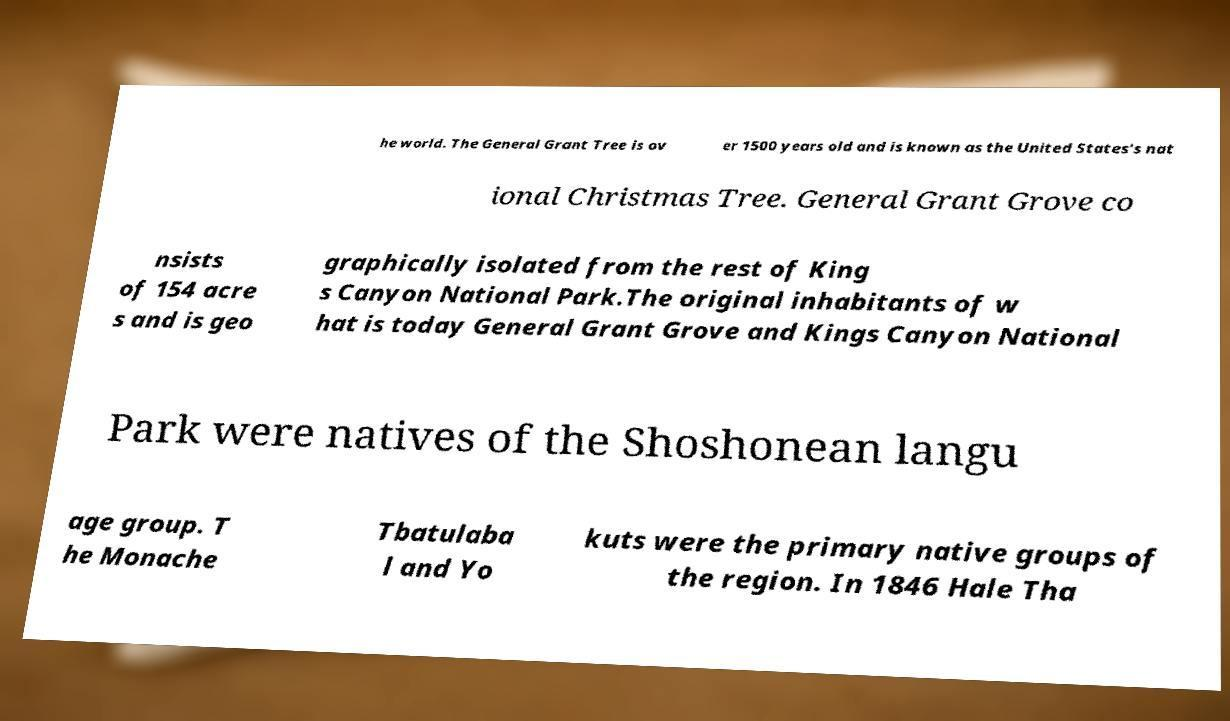Could you extract and type out the text from this image? he world. The General Grant Tree is ov er 1500 years old and is known as the United States's nat ional Christmas Tree. General Grant Grove co nsists of 154 acre s and is geo graphically isolated from the rest of King s Canyon National Park.The original inhabitants of w hat is today General Grant Grove and Kings Canyon National Park were natives of the Shoshonean langu age group. T he Monache Tbatulaba l and Yo kuts were the primary native groups of the region. In 1846 Hale Tha 